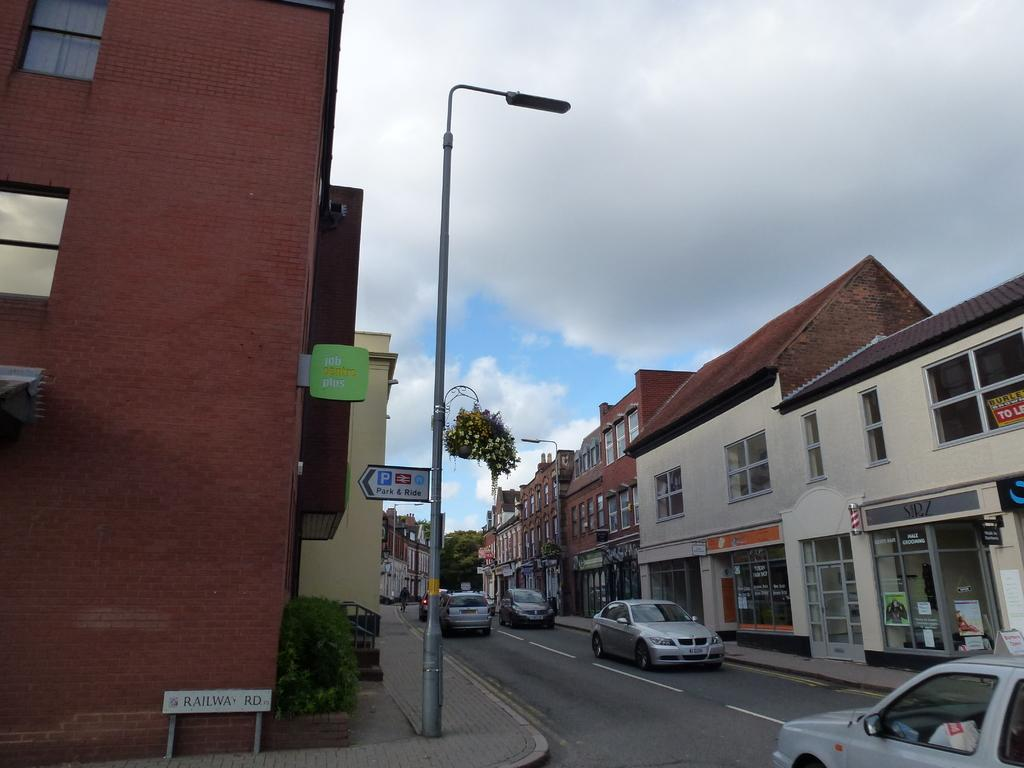What type of structures can be seen in the image? There are buildings in the image. What other natural elements are present in the image? There are trees in the image. What mode of transportation can be seen on the road in the image? There are vehicles on the road in the image. What is attached to the street light in the image? There is a board attached to a street light in the image. What can be seen in the background of the image? The sky is visible in the background of the image. What type of cast can be seen playing baseball in the image? There is no cast or baseball game present in the image. What day of the week is depicted in the image? The day of the week is not mentioned or depicted in the image. 